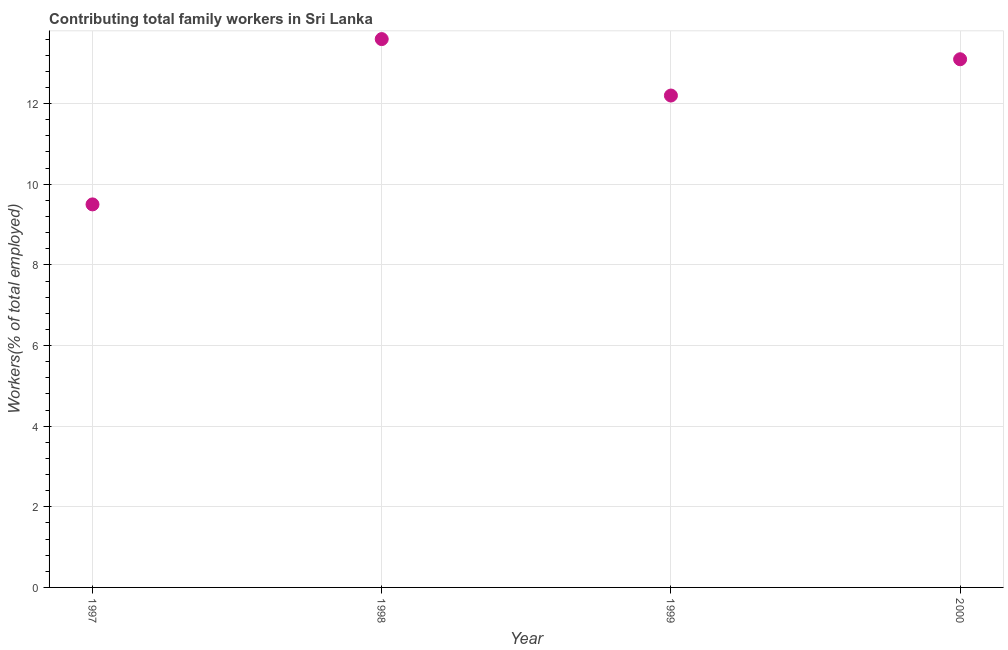Across all years, what is the maximum contributing family workers?
Provide a succinct answer. 13.6. Across all years, what is the minimum contributing family workers?
Provide a succinct answer. 9.5. In which year was the contributing family workers maximum?
Offer a very short reply. 1998. In which year was the contributing family workers minimum?
Provide a succinct answer. 1997. What is the sum of the contributing family workers?
Keep it short and to the point. 48.4. What is the difference between the contributing family workers in 1999 and 2000?
Your answer should be compact. -0.9. What is the average contributing family workers per year?
Your answer should be compact. 12.1. What is the median contributing family workers?
Keep it short and to the point. 12.65. What is the ratio of the contributing family workers in 1997 to that in 1999?
Provide a short and direct response. 0.78. Is the contributing family workers in 1997 less than that in 2000?
Provide a short and direct response. Yes. What is the difference between the highest and the second highest contributing family workers?
Make the answer very short. 0.5. Is the sum of the contributing family workers in 1998 and 2000 greater than the maximum contributing family workers across all years?
Offer a very short reply. Yes. What is the difference between the highest and the lowest contributing family workers?
Keep it short and to the point. 4.1. Does the contributing family workers monotonically increase over the years?
Provide a short and direct response. No. What is the difference between two consecutive major ticks on the Y-axis?
Provide a short and direct response. 2. What is the title of the graph?
Keep it short and to the point. Contributing total family workers in Sri Lanka. What is the label or title of the Y-axis?
Provide a short and direct response. Workers(% of total employed). What is the Workers(% of total employed) in 1997?
Your answer should be compact. 9.5. What is the Workers(% of total employed) in 1998?
Offer a terse response. 13.6. What is the Workers(% of total employed) in 1999?
Your answer should be compact. 12.2. What is the Workers(% of total employed) in 2000?
Ensure brevity in your answer.  13.1. What is the difference between the Workers(% of total employed) in 1997 and 1998?
Your response must be concise. -4.1. What is the difference between the Workers(% of total employed) in 1997 and 2000?
Keep it short and to the point. -3.6. What is the difference between the Workers(% of total employed) in 1998 and 2000?
Your answer should be very brief. 0.5. What is the ratio of the Workers(% of total employed) in 1997 to that in 1998?
Ensure brevity in your answer.  0.7. What is the ratio of the Workers(% of total employed) in 1997 to that in 1999?
Make the answer very short. 0.78. What is the ratio of the Workers(% of total employed) in 1997 to that in 2000?
Give a very brief answer. 0.72. What is the ratio of the Workers(% of total employed) in 1998 to that in 1999?
Keep it short and to the point. 1.11. What is the ratio of the Workers(% of total employed) in 1998 to that in 2000?
Ensure brevity in your answer.  1.04. What is the ratio of the Workers(% of total employed) in 1999 to that in 2000?
Make the answer very short. 0.93. 